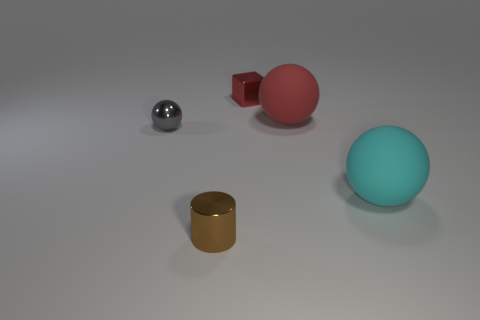There is a small metal thing that is in front of the metal thing left of the brown metallic cylinder; what is its shape?
Offer a terse response. Cylinder. Is there any other thing that is the same color as the metal ball?
Keep it short and to the point. No. There is a rubber sphere that is left of the matte object that is in front of the metal sphere; is there a large cyan sphere in front of it?
Your response must be concise. Yes. There is a tiny object behind the tiny gray metal thing; is its color the same as the ball on the left side of the small red cube?
Provide a short and direct response. No. There is a block that is the same size as the metallic sphere; what is its material?
Make the answer very short. Metal. There is a shiny object that is in front of the large ball in front of the matte thing that is behind the small gray shiny sphere; how big is it?
Your response must be concise. Small. What number of other things are the same material as the small ball?
Provide a succinct answer. 2. There is a shiny cube on the right side of the small brown thing; what size is it?
Your answer should be compact. Small. What number of things are both to the right of the large red thing and in front of the cyan rubber thing?
Ensure brevity in your answer.  0. What is the small cylinder that is to the left of the red object that is on the right side of the block made of?
Keep it short and to the point. Metal. 